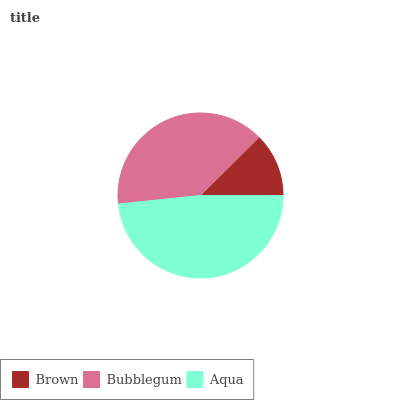Is Brown the minimum?
Answer yes or no. Yes. Is Aqua the maximum?
Answer yes or no. Yes. Is Bubblegum the minimum?
Answer yes or no. No. Is Bubblegum the maximum?
Answer yes or no. No. Is Bubblegum greater than Brown?
Answer yes or no. Yes. Is Brown less than Bubblegum?
Answer yes or no. Yes. Is Brown greater than Bubblegum?
Answer yes or no. No. Is Bubblegum less than Brown?
Answer yes or no. No. Is Bubblegum the high median?
Answer yes or no. Yes. Is Bubblegum the low median?
Answer yes or no. Yes. Is Brown the high median?
Answer yes or no. No. Is Aqua the low median?
Answer yes or no. No. 